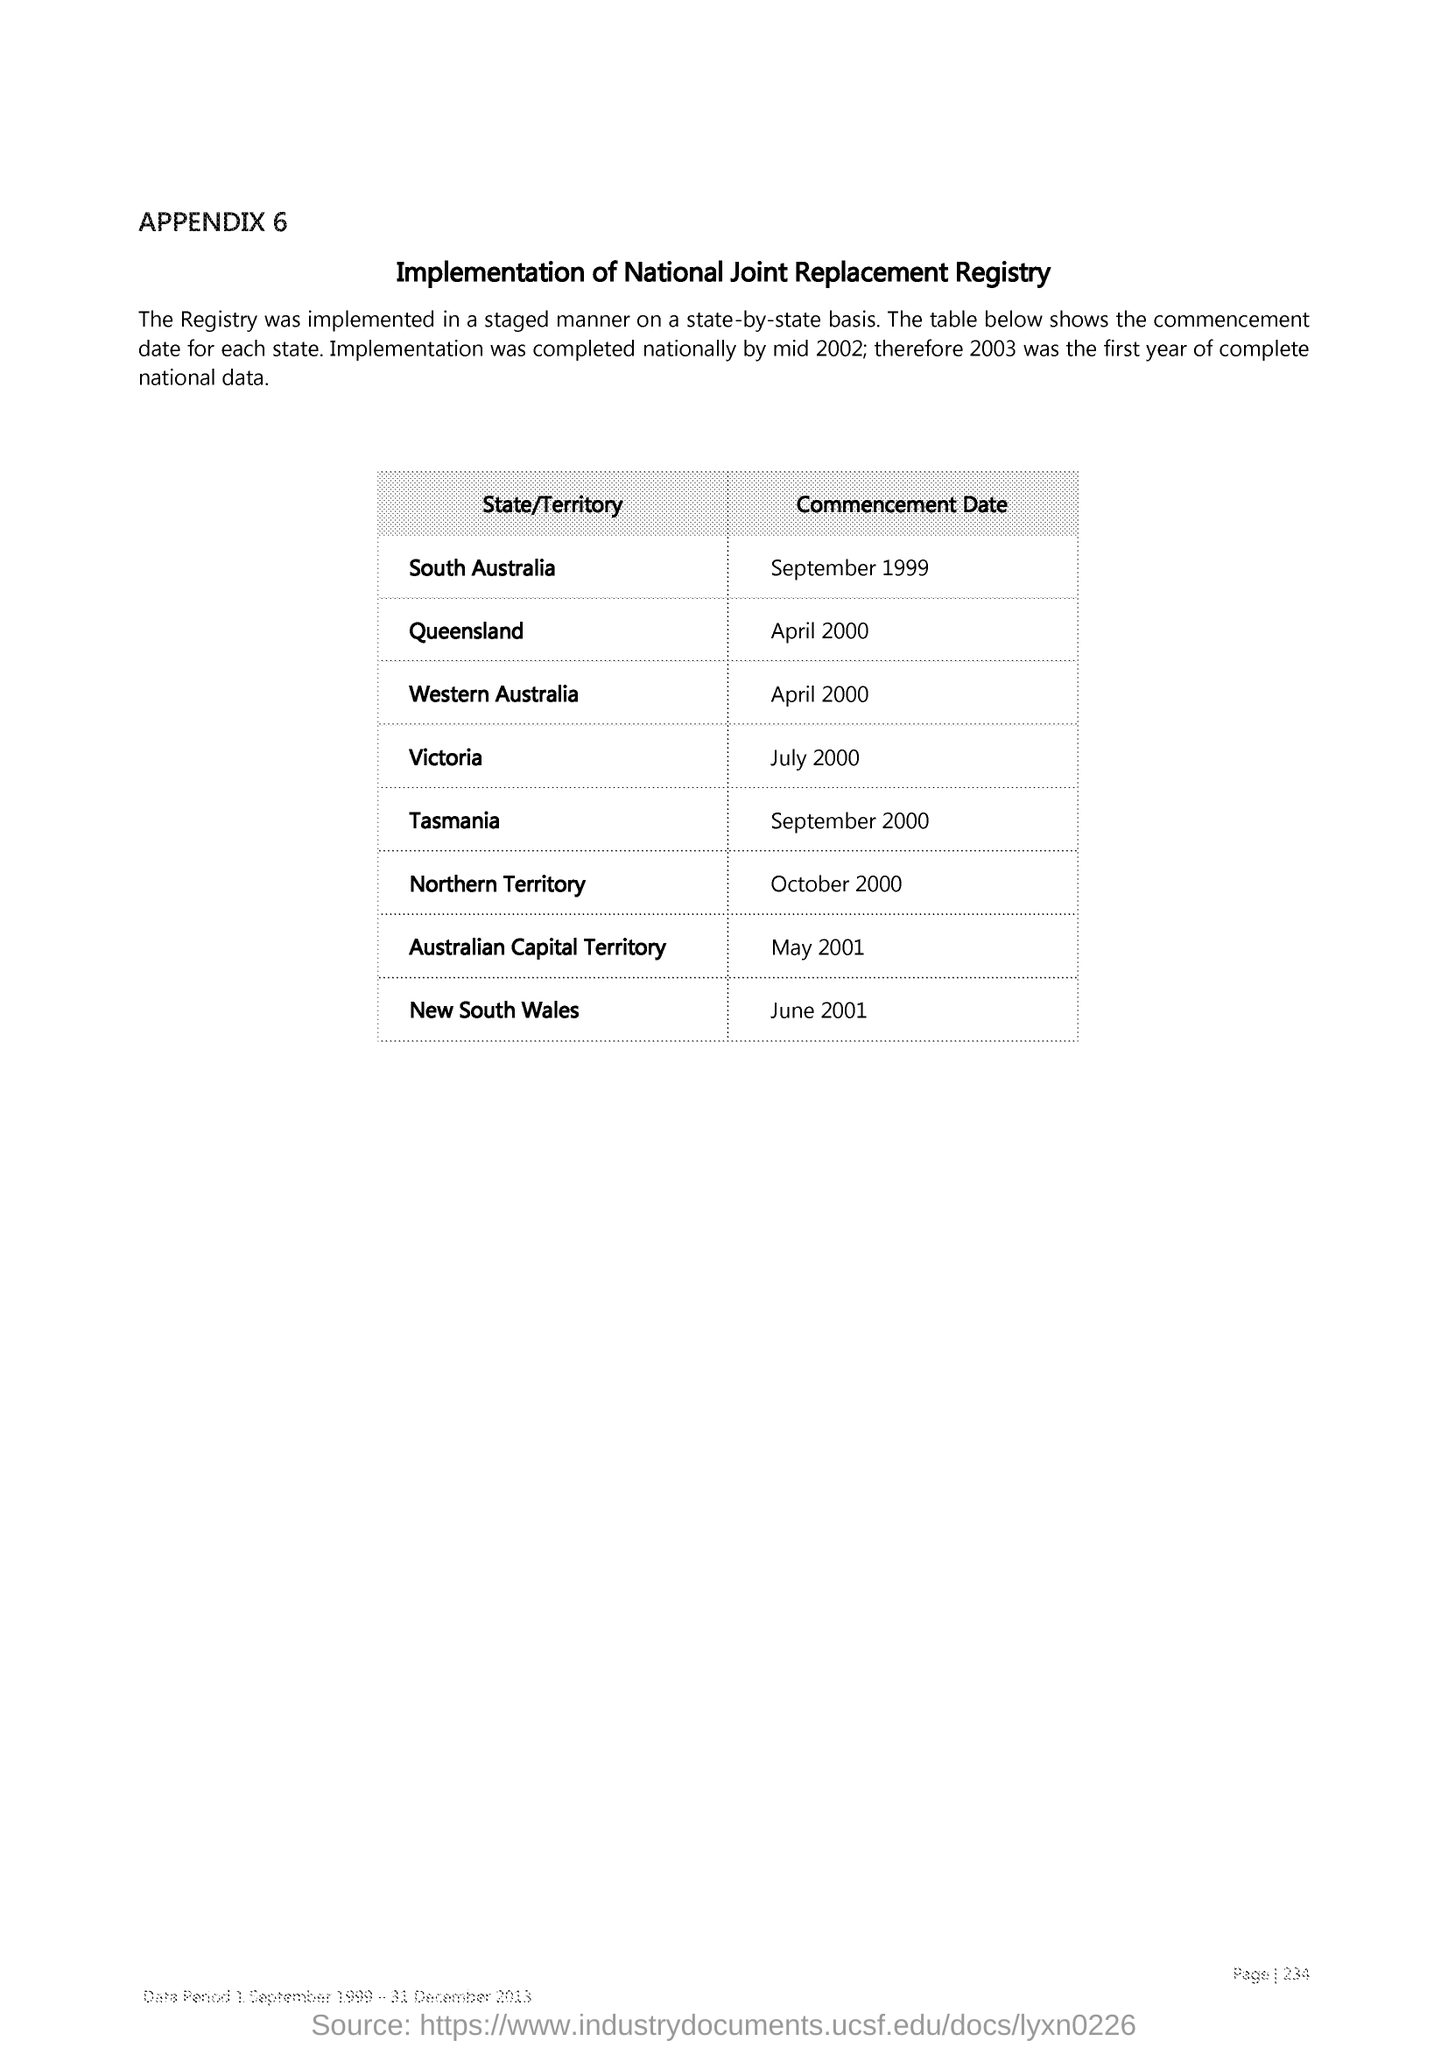The Commencement date of Queensland?
Your answer should be compact. April 2000. The Commencement date of Victoria?
Keep it short and to the point. July 2000. The Commencement date of New South Wales?
Offer a very short reply. June 2001. 